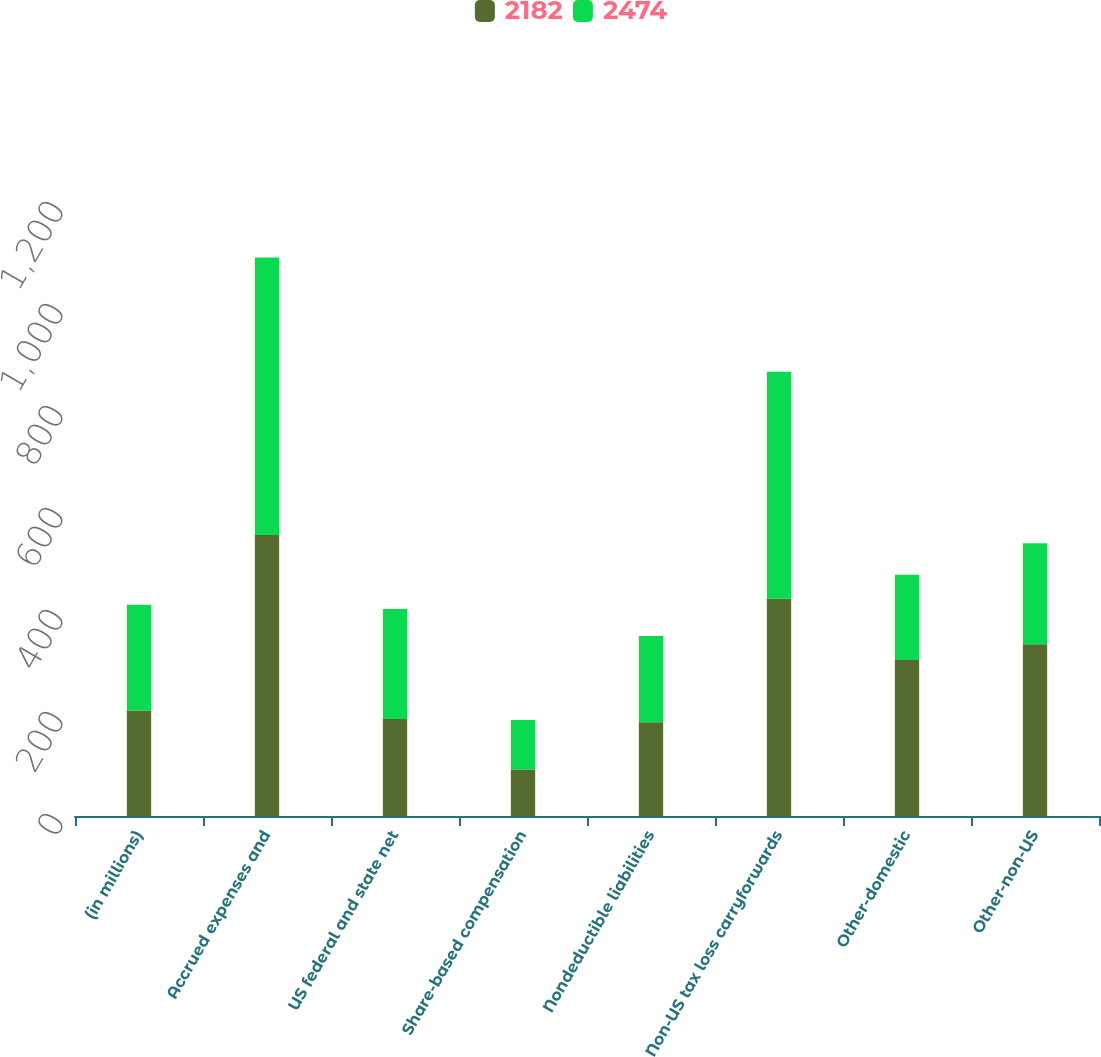Convert chart. <chart><loc_0><loc_0><loc_500><loc_500><stacked_bar_chart><ecel><fcel>(in millions)<fcel>Accrued expenses and<fcel>US federal and state net<fcel>Share-based compensation<fcel>Nondeductible liabilities<fcel>Non-US tax loss carryforwards<fcel>Other-domestic<fcel>Other-non-US<nl><fcel>2182<fcel>207<fcel>551<fcel>190<fcel>91<fcel>184<fcel>426<fcel>306<fcel>337<nl><fcel>2474<fcel>207<fcel>544<fcel>216<fcel>97<fcel>169<fcel>445<fcel>167<fcel>198<nl></chart> 